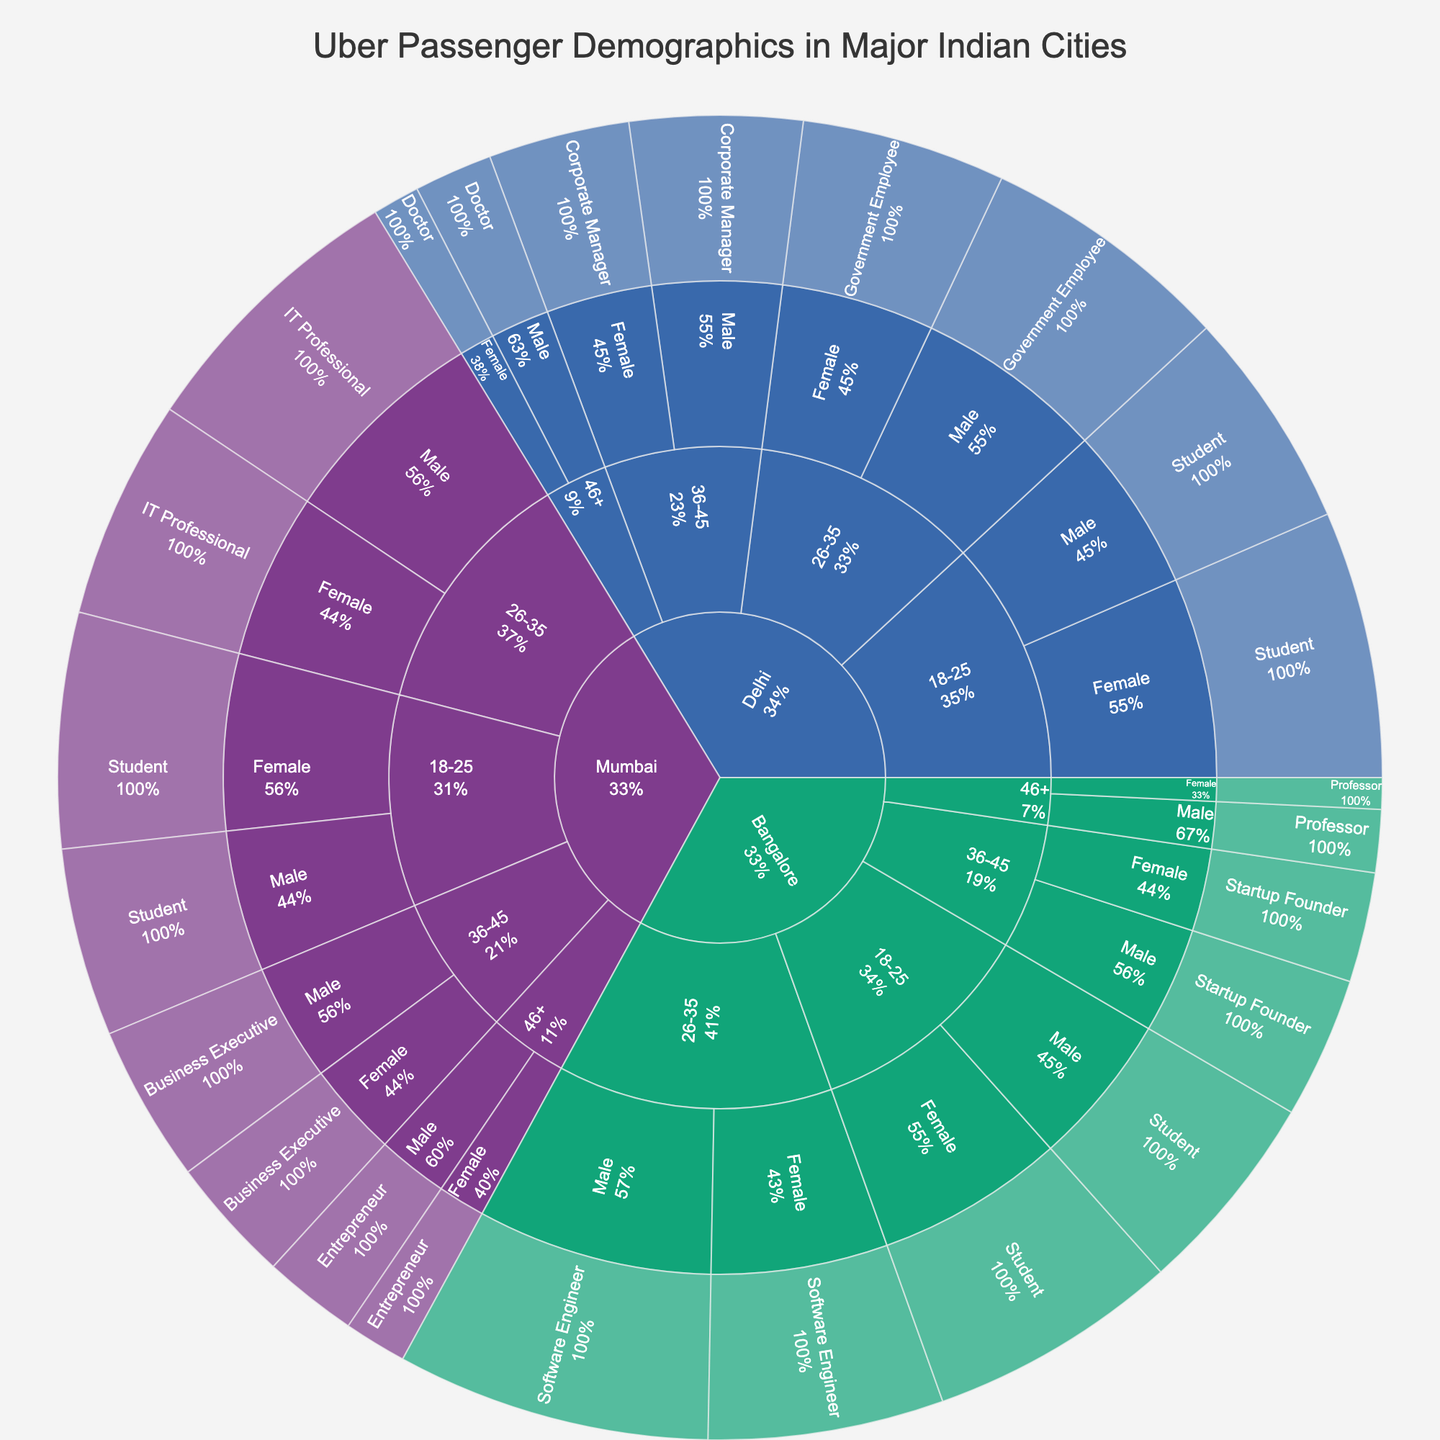How many passengers are there in the age group 18-25 in Mumbai? Look at the "Mumbai" > "18-25" section of the Sunburst Plot. Sum the values for Male and Female students in this section (12 + 15).
Answer: 27 Which occupation has the most male passengers in Bangalore? Focus on the "Bangalore" > "26-35" > "Male" section. The value for Software Engineer (20) is the highest among all occupations listed under male passengers.
Answer: Software Engineer What is the percentage of female passengers in Delhi who are students? Locate the "Delhi" > "18-25" > "Female" section. The value is 17. Then, find the total number of passengers in Delhi (14+17+16+13+11+9+5+3 = 88). The percentage is (17/88)*100%.
Answer: Approximately 19.3% Which city has the highest number of female IT professionals aged 26-35? Compare the "26-35" > "Female" values for IT Professionals across all cities. Mumbai has a value of 14, which is higher than the combined values of government employees and software engineers in the other cities.
Answer: Mumbai What is the total number of passengers in the 36-45 age group across all cities? Sum the values for the 36-45 age group across Mumbai, Delhi, and Bangalore. (10+8) + (11+9) + (9+7) = 54
Answer: 54 How many passengers in total are entrepreneurs in Mumbai? Check the "Mumbai" > "46+" section for both Male (6) and Female (4) entrepreneurs. Then, add these values up.
Answer: 10 Which city has the least number of professors in the 46+ age group? Compare the values for professors under the "46+" section in all cities. Bangalore (6), Mumbai (2), and Delhi (4). Since Mumbai has the least value, it's the answer.
Answer: Mumbai What percentage of the total passengers in Bangalore are female software engineers? Look at "Bangalore" > "26-35" > "Female". The value is 15. Find the total number of passengers in Bangalore (13+16+20+15+9+7+4+2 = 86). The percentage is (15/86)*100%.
Answer: Approximately 17.4% Which age group in Delhi has the highest number of passengers? Compare the total values for different age groups in "Delhi". 18-25 (31), 26-35 (29), 36-45 (20), 46+ (8). The highest is the 18-25 age group.
Answer: 18-25 Are there more male students in Mumbai or Delhi? Check the values for "Male" > "Student" in both cities. Mumbai (12), and Delhi (14). Delhi has more male students.
Answer: Delhi 